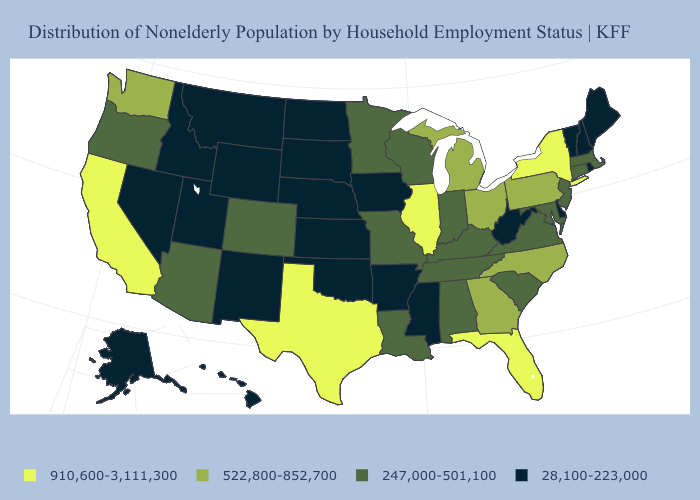What is the value of Virginia?
Write a very short answer. 247,000-501,100. Does Kansas have the highest value in the USA?
Concise answer only. No. Which states have the lowest value in the USA?
Short answer required. Alaska, Arkansas, Delaware, Hawaii, Idaho, Iowa, Kansas, Maine, Mississippi, Montana, Nebraska, Nevada, New Hampshire, New Mexico, North Dakota, Oklahoma, Rhode Island, South Dakota, Utah, Vermont, West Virginia, Wyoming. Does the map have missing data?
Answer briefly. No. What is the value of Montana?
Give a very brief answer. 28,100-223,000. Name the states that have a value in the range 28,100-223,000?
Be succinct. Alaska, Arkansas, Delaware, Hawaii, Idaho, Iowa, Kansas, Maine, Mississippi, Montana, Nebraska, Nevada, New Hampshire, New Mexico, North Dakota, Oklahoma, Rhode Island, South Dakota, Utah, Vermont, West Virginia, Wyoming. Name the states that have a value in the range 28,100-223,000?
Quick response, please. Alaska, Arkansas, Delaware, Hawaii, Idaho, Iowa, Kansas, Maine, Mississippi, Montana, Nebraska, Nevada, New Hampshire, New Mexico, North Dakota, Oklahoma, Rhode Island, South Dakota, Utah, Vermont, West Virginia, Wyoming. What is the value of New York?
Short answer required. 910,600-3,111,300. Name the states that have a value in the range 247,000-501,100?
Write a very short answer. Alabama, Arizona, Colorado, Connecticut, Indiana, Kentucky, Louisiana, Maryland, Massachusetts, Minnesota, Missouri, New Jersey, Oregon, South Carolina, Tennessee, Virginia, Wisconsin. Does Connecticut have the same value as Arkansas?
Quick response, please. No. Does New Hampshire have the same value as Wisconsin?
Give a very brief answer. No. Name the states that have a value in the range 28,100-223,000?
Give a very brief answer. Alaska, Arkansas, Delaware, Hawaii, Idaho, Iowa, Kansas, Maine, Mississippi, Montana, Nebraska, Nevada, New Hampshire, New Mexico, North Dakota, Oklahoma, Rhode Island, South Dakota, Utah, Vermont, West Virginia, Wyoming. Does Washington have a higher value than Illinois?
Concise answer only. No. What is the value of North Carolina?
Short answer required. 522,800-852,700. Name the states that have a value in the range 28,100-223,000?
Give a very brief answer. Alaska, Arkansas, Delaware, Hawaii, Idaho, Iowa, Kansas, Maine, Mississippi, Montana, Nebraska, Nevada, New Hampshire, New Mexico, North Dakota, Oklahoma, Rhode Island, South Dakota, Utah, Vermont, West Virginia, Wyoming. 